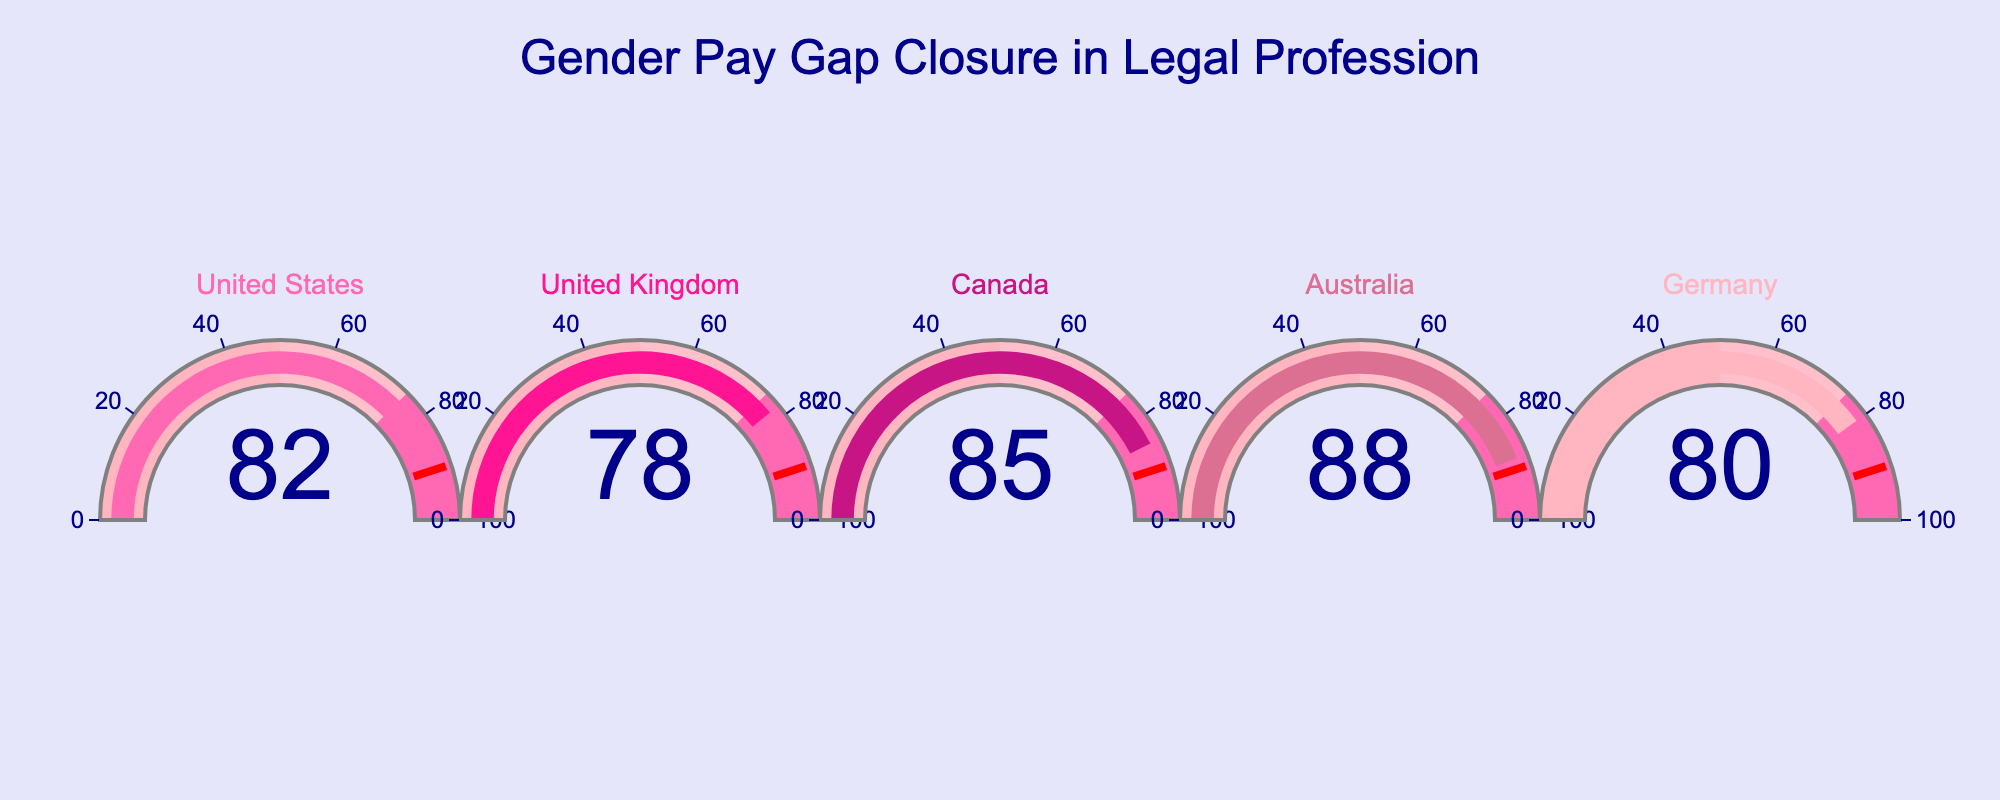what is the highest percentage of gender pay gap closure? The highest value on the gauge charts represents the highest percentage. Here, we see the highest percentage is 88% from Australia.
Answer: 88% which country has closed 82% of its gender pay gap? By matching the percentage to the corresponding country, we can see that the United States has closed 82% of its gender pay gap.
Answer: United States how many countries have closed more than 80% of their gender pay gap? Observing the percentages on the gauges, we see that the United States (82%), Canada (85%), and Australia (88%) have closed more than 80% of their gender pay gap. Thus, there are 3 countries.
Answer: 3 what is the combined percentage of gender pay gap closure of the United States and Germany? The percentage for the United States is 82% and for Germany is 80%. Adding these together gives us 82 + 80 = 162%.
Answer: 162% which country has the lowest percentage of gender pay gap closure? The lowest percentage on the gauge charts corresponds to the United Kingdom, with 78%.
Answer: United Kingdom by how many percentage points has Australia closed more of its gender pay gap compared to Germany? Subtracting Germany's percentage from Australia's gives us 88 - 80 = 8 percentage points.
Answer: 8 what is the average percentage of gender pay gap closure across all five countries? Adding all the percentages (82 + 78 + 85 + 88 + 80) and then dividing by the number of countries (5) gives us (82 + 78 + 85 + 88 + 80) / 5 = 82.6%.
Answer: 82.6% which countries show a gender pay gap closure within the 75-100% range? All the gauge charts that indicate percentages within the 75-100% range will qualify. These countries are the United States (82%), United Kingdom (78%), Canada (85%), Australia (88%), and Germany (80%).
Answer: United States, United Kingdom, Canada, Australia, Germany if the threshold value is 90%, which countries are below this threshold? All the countries listed are below the 90% threshold as no gauge reaches 90%. The countries are the United States, United Kingdom, Canada, Australia, and Germany.
Answer: All calculate the difference in gender pay gap closure percentages between the country with the highest and the country with the lowest closure percentages. The highest percentage is 88% (Australia) and the lowest is 78% (United Kingdom). Subtracting these gives us 88 - 78 = 10 percentage points.
Answer: 10 